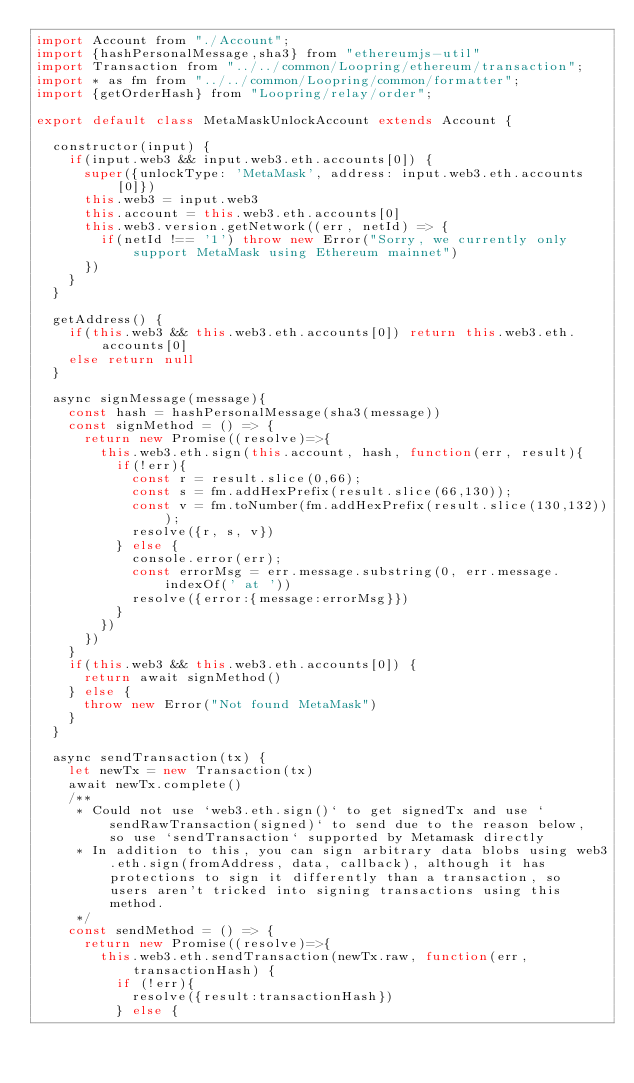Convert code to text. <code><loc_0><loc_0><loc_500><loc_500><_JavaScript_>import Account from "./Account";
import {hashPersonalMessage,sha3} from "ethereumjs-util"
import Transaction from "../../common/Loopring/ethereum/transaction";
import * as fm from "../../common/Loopring/common/formatter";
import {getOrderHash} from "Loopring/relay/order";

export default class MetaMaskUnlockAccount extends Account {

  constructor(input) {
    if(input.web3 && input.web3.eth.accounts[0]) {
      super({unlockType: 'MetaMask', address: input.web3.eth.accounts[0]})
      this.web3 = input.web3
      this.account = this.web3.eth.accounts[0]
      this.web3.version.getNetwork((err, netId) => {
        if(netId !== '1') throw new Error("Sorry, we currently only support MetaMask using Ethereum mainnet")
      })
    }
  }

  getAddress() {
    if(this.web3 && this.web3.eth.accounts[0]) return this.web3.eth.accounts[0]
    else return null
  }

  async signMessage(message){
    const hash = hashPersonalMessage(sha3(message))
    const signMethod = () => {
      return new Promise((resolve)=>{
        this.web3.eth.sign(this.account, hash, function(err, result){
          if(!err){
            const r = result.slice(0,66);
            const s = fm.addHexPrefix(result.slice(66,130));
            const v = fm.toNumber(fm.addHexPrefix(result.slice(130,132)));
            resolve({r, s, v})
          } else {
            console.error(err);
            const errorMsg = err.message.substring(0, err.message.indexOf(' at '))
            resolve({error:{message:errorMsg}})
          }
        })
      })
    }
    if(this.web3 && this.web3.eth.accounts[0]) {
      return await signMethod()
    } else {
      throw new Error("Not found MetaMask")
    }
  }

  async sendTransaction(tx) {
    let newTx = new Transaction(tx)
    await newTx.complete()
    /**
     * Could not use `web3.eth.sign()` to get signedTx and use `sendRawTransaction(signed)` to send due to the reason below, so use `sendTransaction` supported by Metamask directly
     * In addition to this, you can sign arbitrary data blobs using web3.eth.sign(fromAddress, data, callback), although it has protections to sign it differently than a transaction, so users aren't tricked into signing transactions using this method.
     */
    const sendMethod = () => {
      return new Promise((resolve)=>{
        this.web3.eth.sendTransaction(newTx.raw, function(err, transactionHash) {
          if (!err){
            resolve({result:transactionHash})
          } else {</code> 